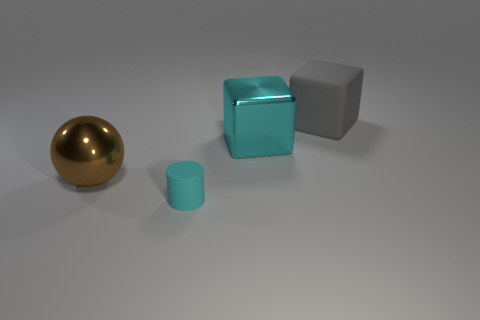Is there anything else that has the same shape as the tiny thing?
Your response must be concise. No. Are there any gray rubber blocks that are in front of the metallic thing on the left side of the small cylinder in front of the gray block?
Keep it short and to the point. No. There is a cylinder that is made of the same material as the big gray block; what color is it?
Offer a terse response. Cyan. Does the large metallic object on the right side of the cylinder have the same color as the large ball?
Keep it short and to the point. No. How many balls are tiny brown metallic things or tiny cyan rubber objects?
Ensure brevity in your answer.  0. How big is the rubber object behind the object that is on the left side of the rubber object left of the large matte block?
Provide a short and direct response. Large. What shape is the cyan thing that is the same size as the brown metallic object?
Provide a succinct answer. Cube. What shape is the tiny object?
Provide a short and direct response. Cylinder. Are the block in front of the large gray matte thing and the brown sphere made of the same material?
Provide a succinct answer. Yes. There is a metal thing that is left of the thing in front of the sphere; what is its size?
Your answer should be very brief. Large. 